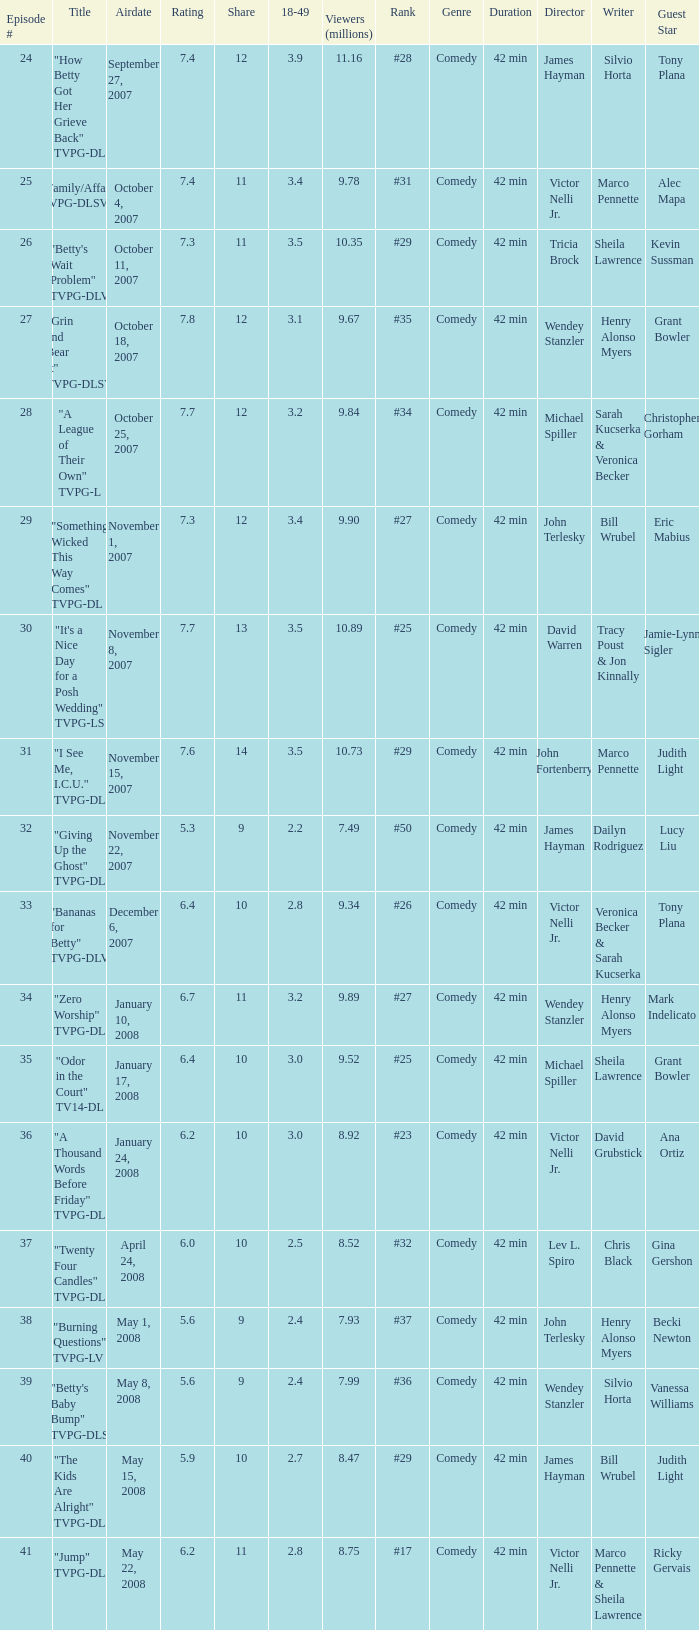What is the Airdate of the episode that ranked #29 and had a share greater than 10? May 15, 2008. 